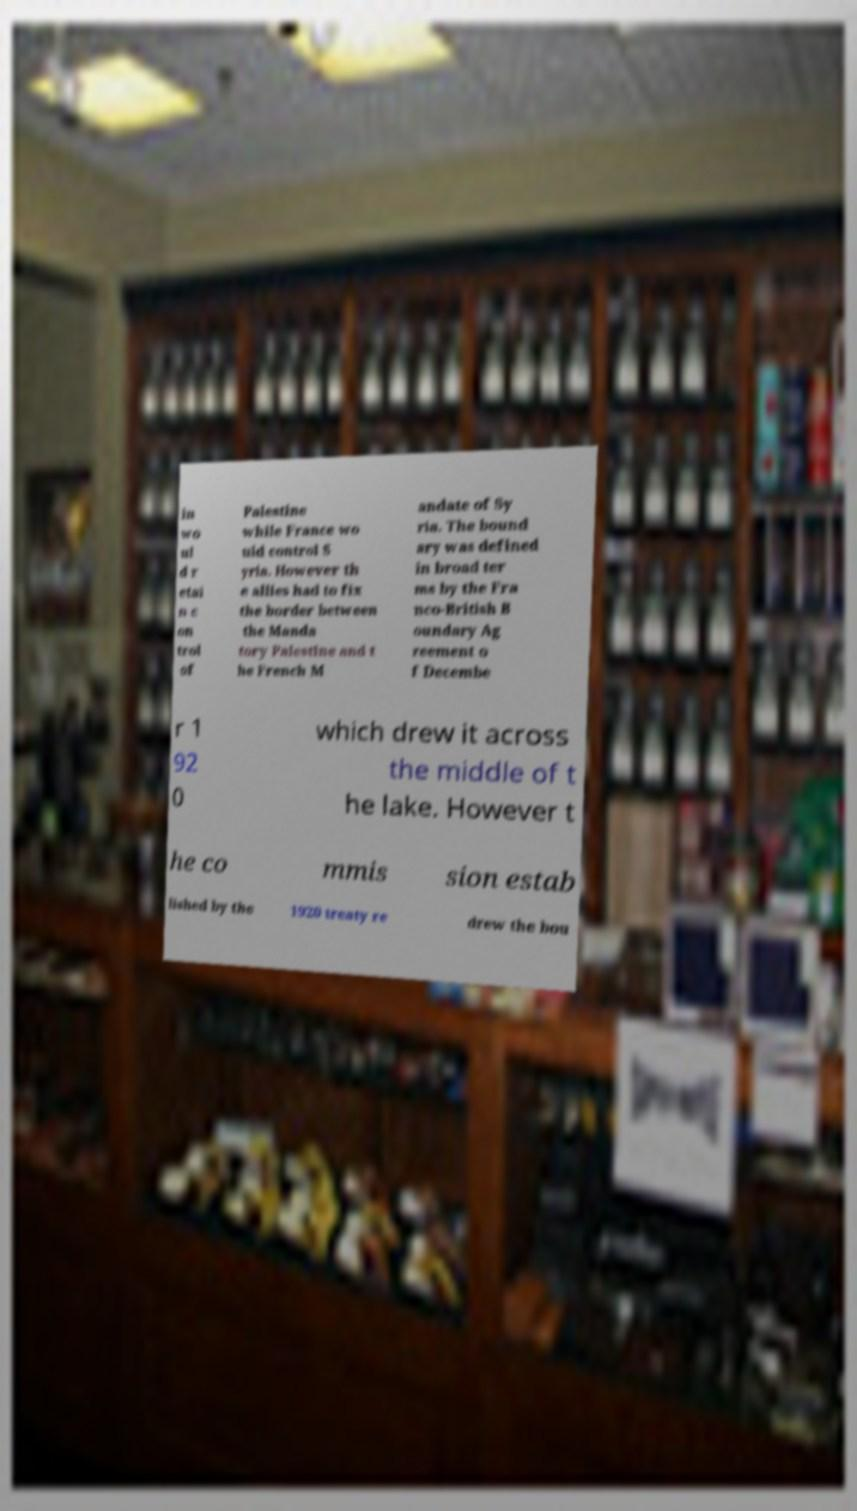There's text embedded in this image that I need extracted. Can you transcribe it verbatim? in wo ul d r etai n c on trol of Palestine while France wo uld control S yria. However th e allies had to fix the border between the Manda tory Palestine and t he French M andate of Sy ria. The bound ary was defined in broad ter ms by the Fra nco-British B oundary Ag reement o f Decembe r 1 92 0 which drew it across the middle of t he lake. However t he co mmis sion estab lished by the 1920 treaty re drew the bou 